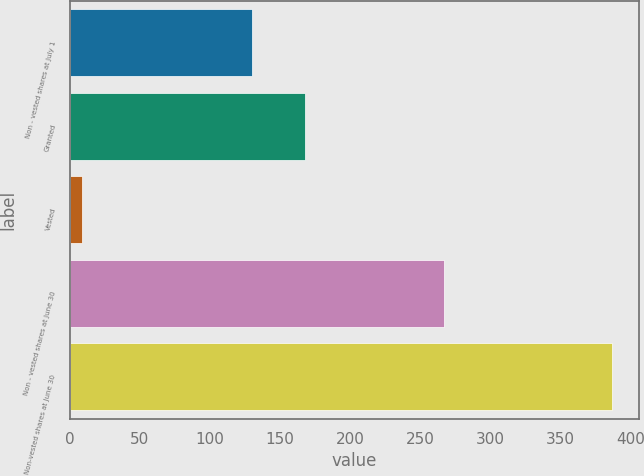<chart> <loc_0><loc_0><loc_500><loc_500><bar_chart><fcel>Non - vested shares at July 1<fcel>Granted<fcel>Vested<fcel>Non - vested shares at June 30<fcel>Non-vested shares at June 30<nl><fcel>130<fcel>167.8<fcel>9<fcel>267<fcel>387<nl></chart> 